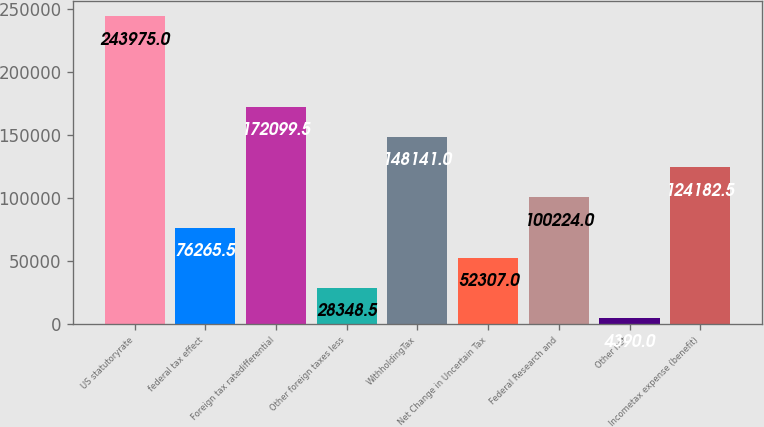<chart> <loc_0><loc_0><loc_500><loc_500><bar_chart><fcel>US statutoryrate<fcel>federal tax effect<fcel>Foreign tax ratedifferential<fcel>Other foreign taxes less<fcel>WithholdingTax<fcel>Net Change in Uncertain Tax<fcel>Federal Research and<fcel>Other net<fcel>Incometax expense (benefit)<nl><fcel>243975<fcel>76265.5<fcel>172100<fcel>28348.5<fcel>148141<fcel>52307<fcel>100224<fcel>4390<fcel>124182<nl></chart> 